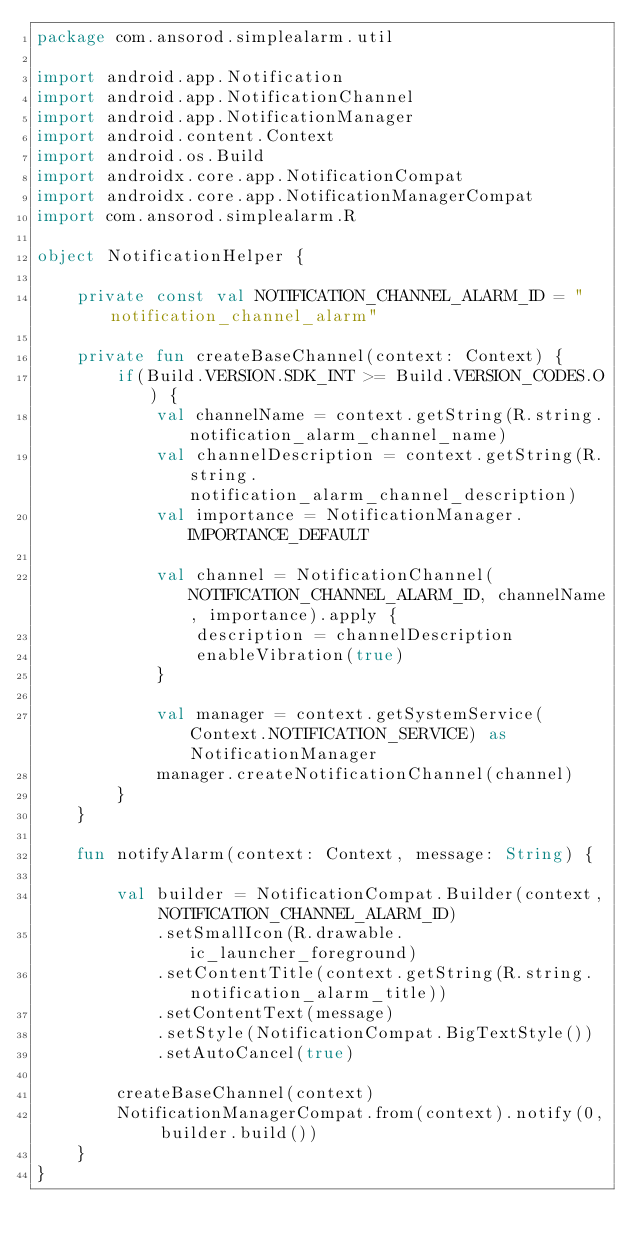Convert code to text. <code><loc_0><loc_0><loc_500><loc_500><_Kotlin_>package com.ansorod.simplealarm.util

import android.app.Notification
import android.app.NotificationChannel
import android.app.NotificationManager
import android.content.Context
import android.os.Build
import androidx.core.app.NotificationCompat
import androidx.core.app.NotificationManagerCompat
import com.ansorod.simplealarm.R

object NotificationHelper {

    private const val NOTIFICATION_CHANNEL_ALARM_ID = "notification_channel_alarm"

    private fun createBaseChannel(context: Context) {
        if(Build.VERSION.SDK_INT >= Build.VERSION_CODES.O) {
            val channelName = context.getString(R.string.notification_alarm_channel_name)
            val channelDescription = context.getString(R.string.notification_alarm_channel_description)
            val importance = NotificationManager.IMPORTANCE_DEFAULT

            val channel = NotificationChannel(NOTIFICATION_CHANNEL_ALARM_ID, channelName, importance).apply {
                description = channelDescription
                enableVibration(true)
            }

            val manager = context.getSystemService(Context.NOTIFICATION_SERVICE) as NotificationManager
            manager.createNotificationChannel(channel)
        }
    }

    fun notifyAlarm(context: Context, message: String) {

        val builder = NotificationCompat.Builder(context, NOTIFICATION_CHANNEL_ALARM_ID)
            .setSmallIcon(R.drawable.ic_launcher_foreground)
            .setContentTitle(context.getString(R.string.notification_alarm_title))
            .setContentText(message)
            .setStyle(NotificationCompat.BigTextStyle())
            .setAutoCancel(true)

        createBaseChannel(context)
        NotificationManagerCompat.from(context).notify(0, builder.build())
    }
}</code> 